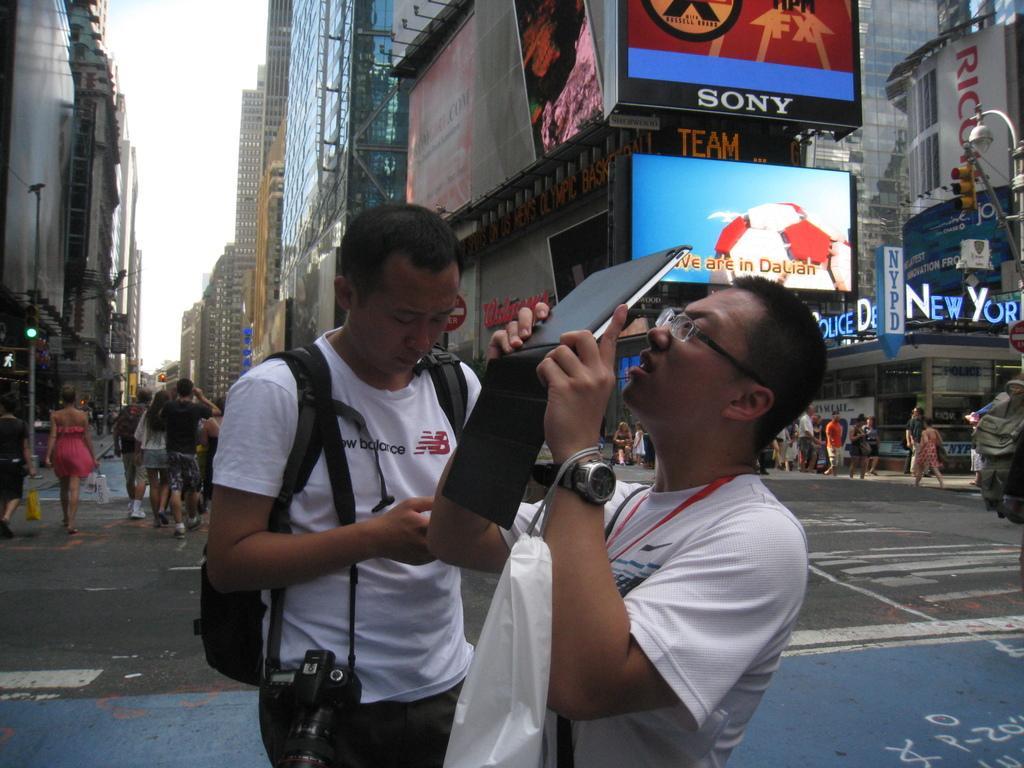In one or two sentences, can you explain what this image depicts? In the center of the image we can see two people standing on the road. In that a man is holding a laptop and and the other is wearing a bag and a camera. On the backside we can see a group of people walking on the road. We can also see some buildings with boards on it, street poles, a signboard and the sky which looks cloudy. 